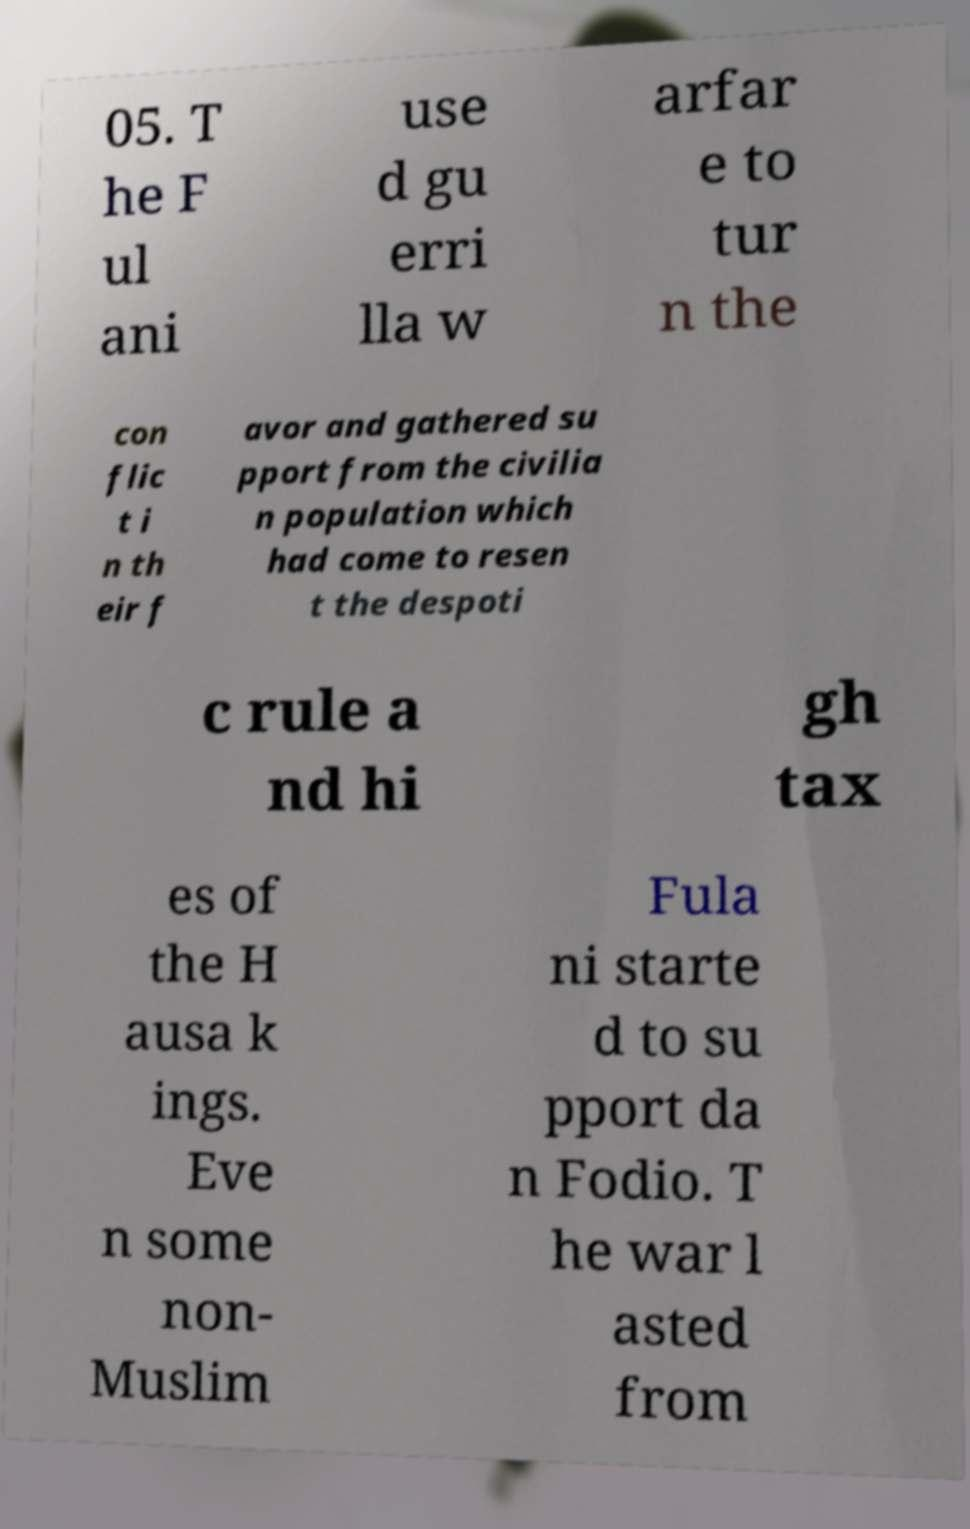Can you accurately transcribe the text from the provided image for me? 05. T he F ul ani use d gu erri lla w arfar e to tur n the con flic t i n th eir f avor and gathered su pport from the civilia n population which had come to resen t the despoti c rule a nd hi gh tax es of the H ausa k ings. Eve n some non- Muslim Fula ni starte d to su pport da n Fodio. T he war l asted from 